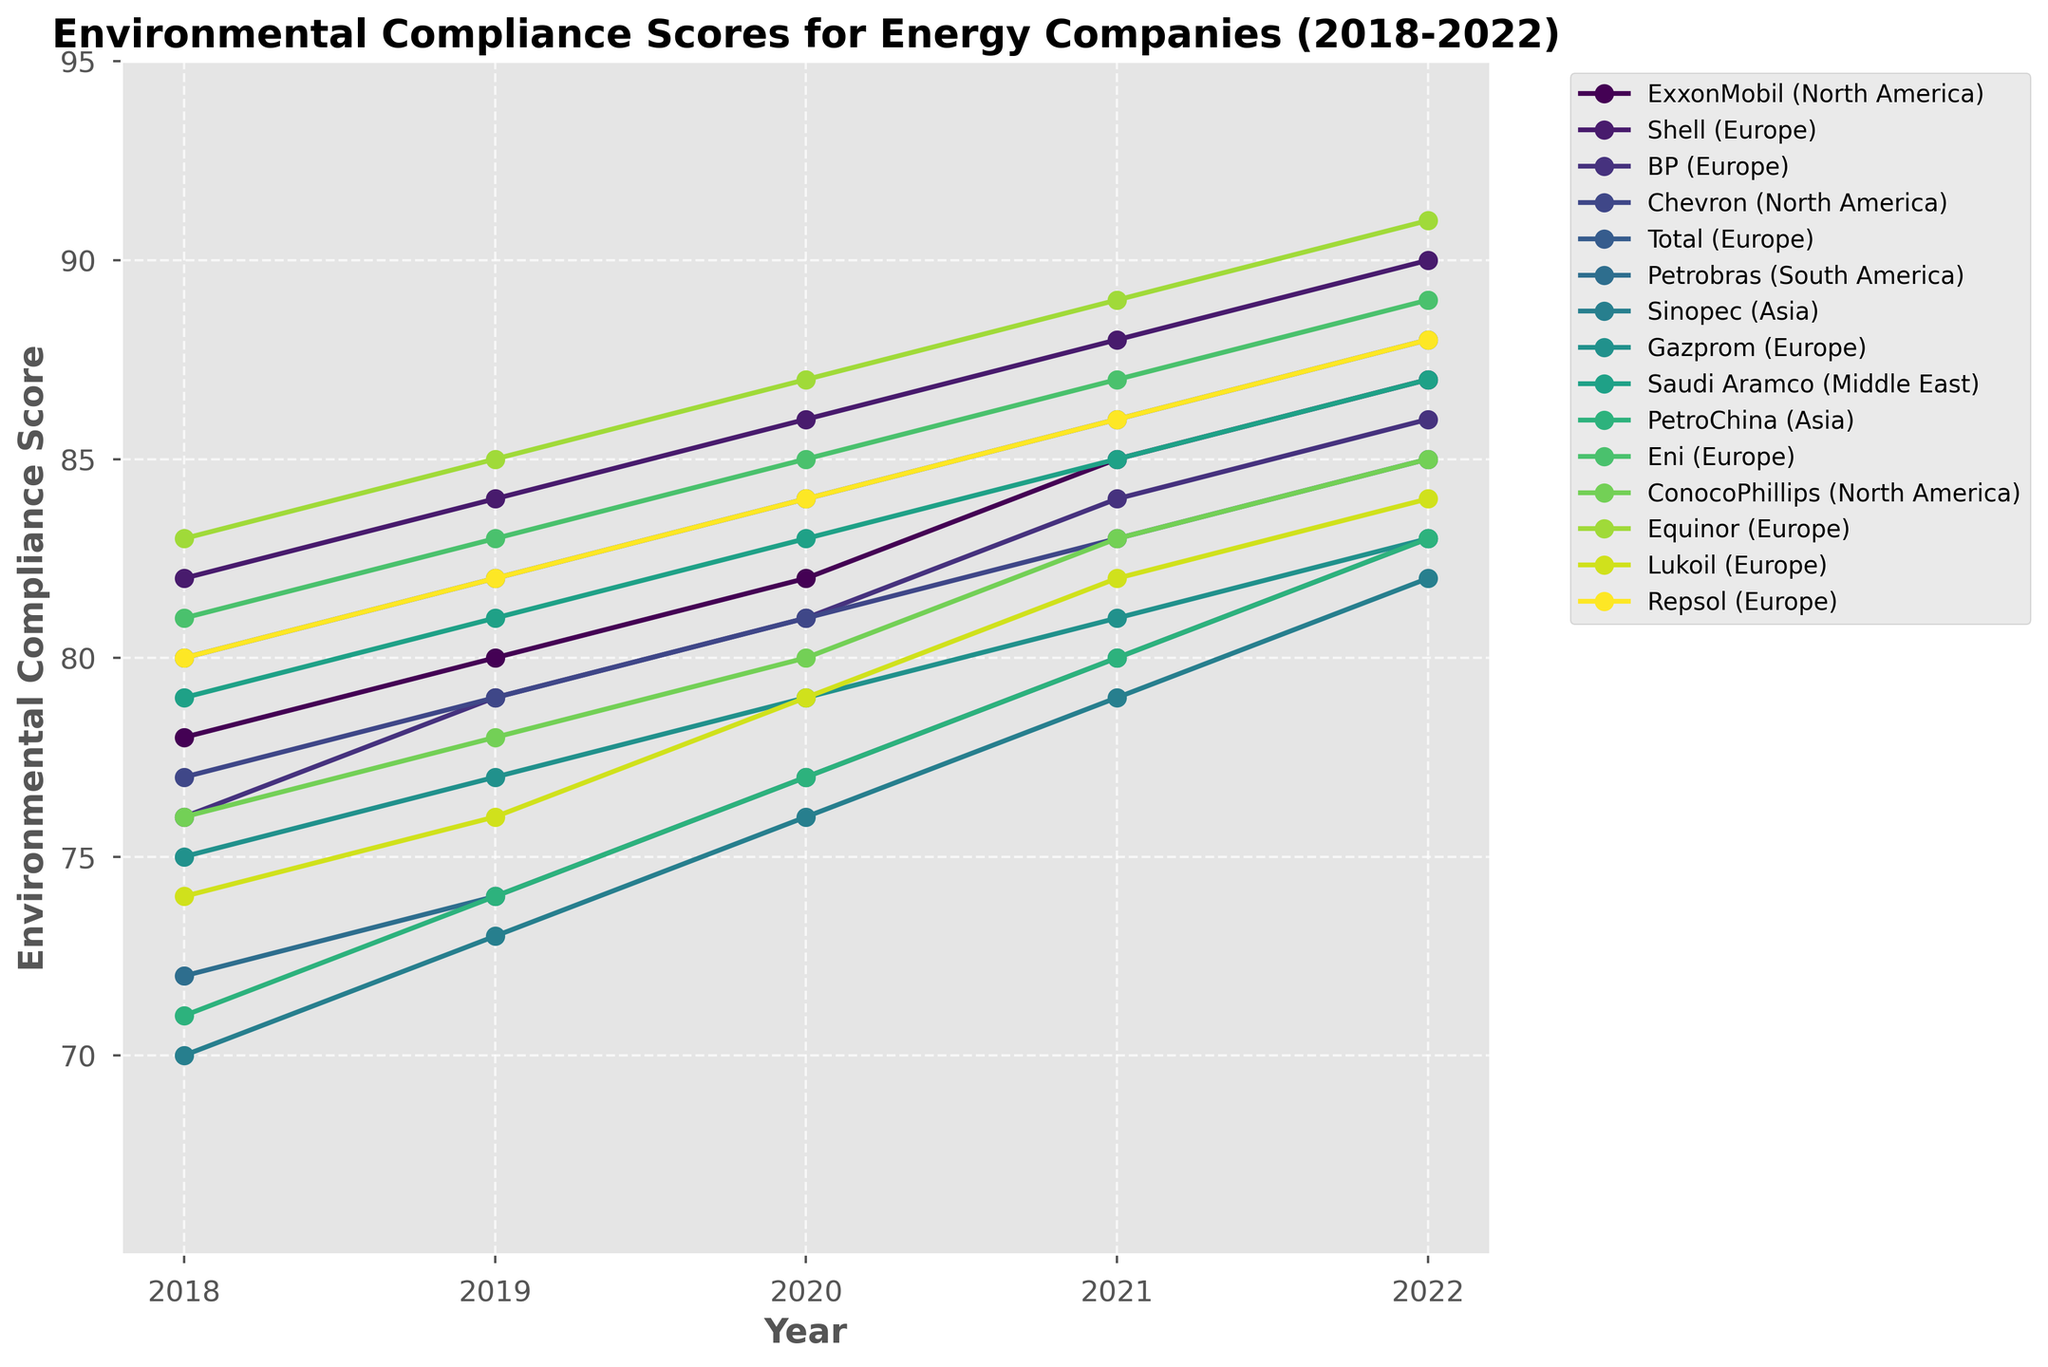Which company has the highest environmental compliance score in 2022? Look at the 2022 column, identify the highest value which is 91, and find the corresponding company.
Answer: Equinor How did Petrobas's environmental compliance score change from 2018 to 2022? Compare Petrobras's scores: 72 in 2018 and 83 in 2022, calculate the difference (83 - 72).
Answer: Increased by 11 Among companies from Europe, which one showed the highest score increase from 2018 to 2022? Compare the scores of European companies over the specified period. Identify the differences: Shell (8), BP (10), Total (8), Gazprom (8), Eni (8), Lukoil (10), Repsol (8), Equinor (8).
Answer: Lukoil & BP (10) Which region had the highest overall average compliance score in 2022? Calculate average scores for each region for 2022 and compare: North America ((87 + 85 + 85)/3), Europe ((90 + 86 + 88 + 83 + 89 + 84 + 88 + 91)/8), South America (83), Asia ((82 + 83)/2), Middle East (87).
Answer: Europe Which company's score had no decrease between 2018 to 2022? Look at the scores for each company and verify if none are decreasing: All companies show consistent scores or increases.
Answer: All companies What was the average score increase for Sinopec between each year from 2018 to 2022? Calculate the increases and average them: (73-70) + (76-73) + (79-76) + (82-79). Then, Average = (3+3+3+3) / 4.
Answer: 3 per year Which company in North America showed the least improvement from 2018 to 2022? Compare score differences: ExxonMobil (87-78), Chevron (85-77), ConocoPhillips (85-76). The smallest increment is 9.
Answer: ConocoPhillips What is the range of compliance scores for Shell from 2018 to 2022? Find the minimum and maximum scores for Shell over the specified years. Range = Maximum - Minimum, i.e., 90 - 82.
Answer: 8 What is the average compliance score for Chevron from 2018 to 2022? Sum the scores for each year and divide by the number of years: (77 + 79 + 81 + 83 + 85) / 5.
Answer: 81 Which company has shown the most consistent performance over the years (least variance in scores)? Calculate the variance for each company and find the one with the lowest: a lower difference between maximum and minimum value indicates more consistency. For example, (85-77), (85-79) for companies can be compared.
Answer: Equinor 